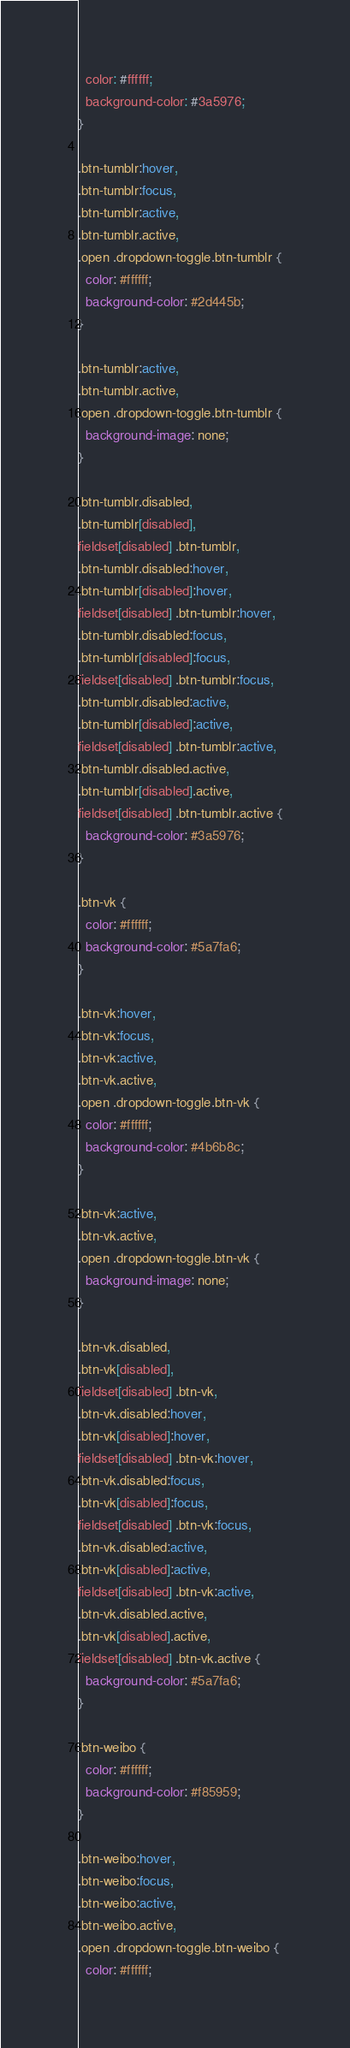<code> <loc_0><loc_0><loc_500><loc_500><_CSS_>  color: #ffffff;
  background-color: #3a5976;
}

.btn-tumblr:hover,
.btn-tumblr:focus,
.btn-tumblr:active,
.btn-tumblr.active,
.open .dropdown-toggle.btn-tumblr {
  color: #ffffff;
  background-color: #2d445b;
}

.btn-tumblr:active,
.btn-tumblr.active,
.open .dropdown-toggle.btn-tumblr {
  background-image: none;
}

.btn-tumblr.disabled,
.btn-tumblr[disabled],
fieldset[disabled] .btn-tumblr,
.btn-tumblr.disabled:hover,
.btn-tumblr[disabled]:hover,
fieldset[disabled] .btn-tumblr:hover,
.btn-tumblr.disabled:focus,
.btn-tumblr[disabled]:focus,
fieldset[disabled] .btn-tumblr:focus,
.btn-tumblr.disabled:active,
.btn-tumblr[disabled]:active,
fieldset[disabled] .btn-tumblr:active,
.btn-tumblr.disabled.active,
.btn-tumblr[disabled].active,
fieldset[disabled] .btn-tumblr.active {
  background-color: #3a5976;
}

.btn-vk {
  color: #ffffff;
  background-color: #5a7fa6;
}

.btn-vk:hover,
.btn-vk:focus,
.btn-vk:active,
.btn-vk.active,
.open .dropdown-toggle.btn-vk {
  color: #ffffff;
  background-color: #4b6b8c;
}

.btn-vk:active,
.btn-vk.active,
.open .dropdown-toggle.btn-vk {
  background-image: none;
}

.btn-vk.disabled,
.btn-vk[disabled],
fieldset[disabled] .btn-vk,
.btn-vk.disabled:hover,
.btn-vk[disabled]:hover,
fieldset[disabled] .btn-vk:hover,
.btn-vk.disabled:focus,
.btn-vk[disabled]:focus,
fieldset[disabled] .btn-vk:focus,
.btn-vk.disabled:active,
.btn-vk[disabled]:active,
fieldset[disabled] .btn-vk:active,
.btn-vk.disabled.active,
.btn-vk[disabled].active,
fieldset[disabled] .btn-vk.active {
  background-color: #5a7fa6;
}

.btn-weibo {
  color: #ffffff;
  background-color: #f85959;
}

.btn-weibo:hover,
.btn-weibo:focus,
.btn-weibo:active,
.btn-weibo.active,
.open .dropdown-toggle.btn-weibo {
  color: #ffffff;</code> 